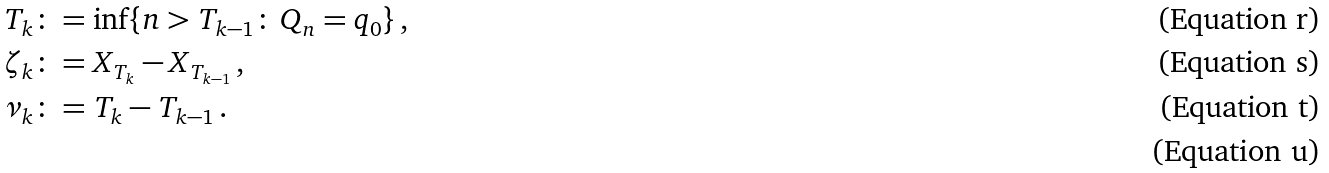<formula> <loc_0><loc_0><loc_500><loc_500>T _ { k } & \colon = \inf \{ n > T _ { k - 1 } \colon \, Q _ { n } = q _ { 0 } \} \, , \\ \zeta _ { k } & \colon = X _ { T _ { k } } - X _ { T _ { k - 1 } } \, , \\ \nu _ { k } & \colon = T _ { k } - T _ { k - 1 } \, . \\</formula> 